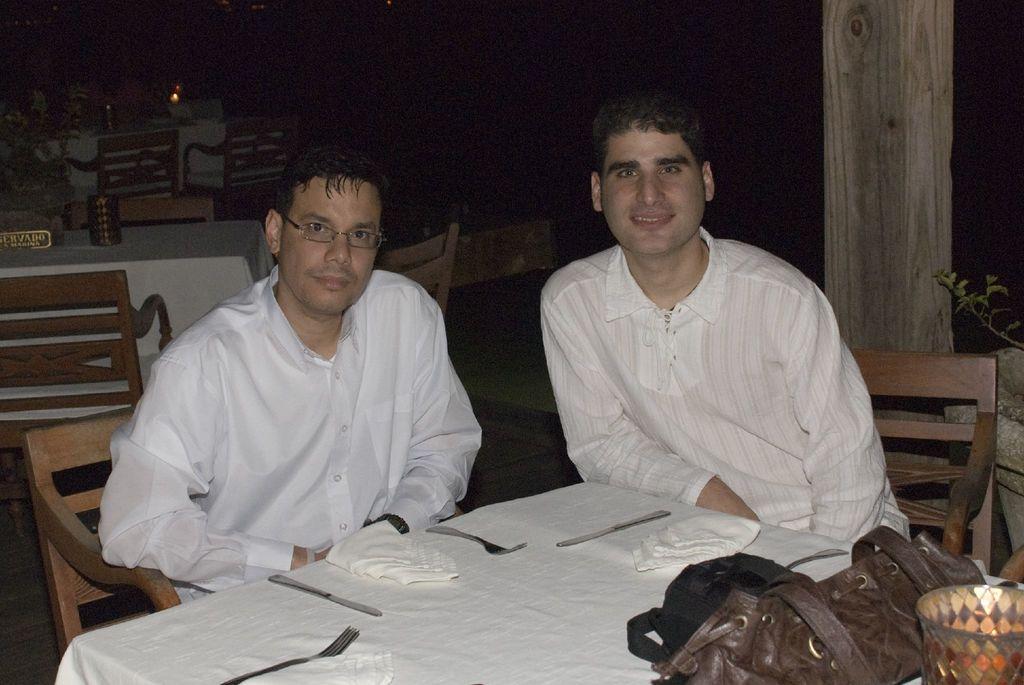Can you describe this image briefly? In this image I can see two men are sitting on the chairs, they wore white color shirts, at the bottom there is the dining table, there are knives and forks on it. 